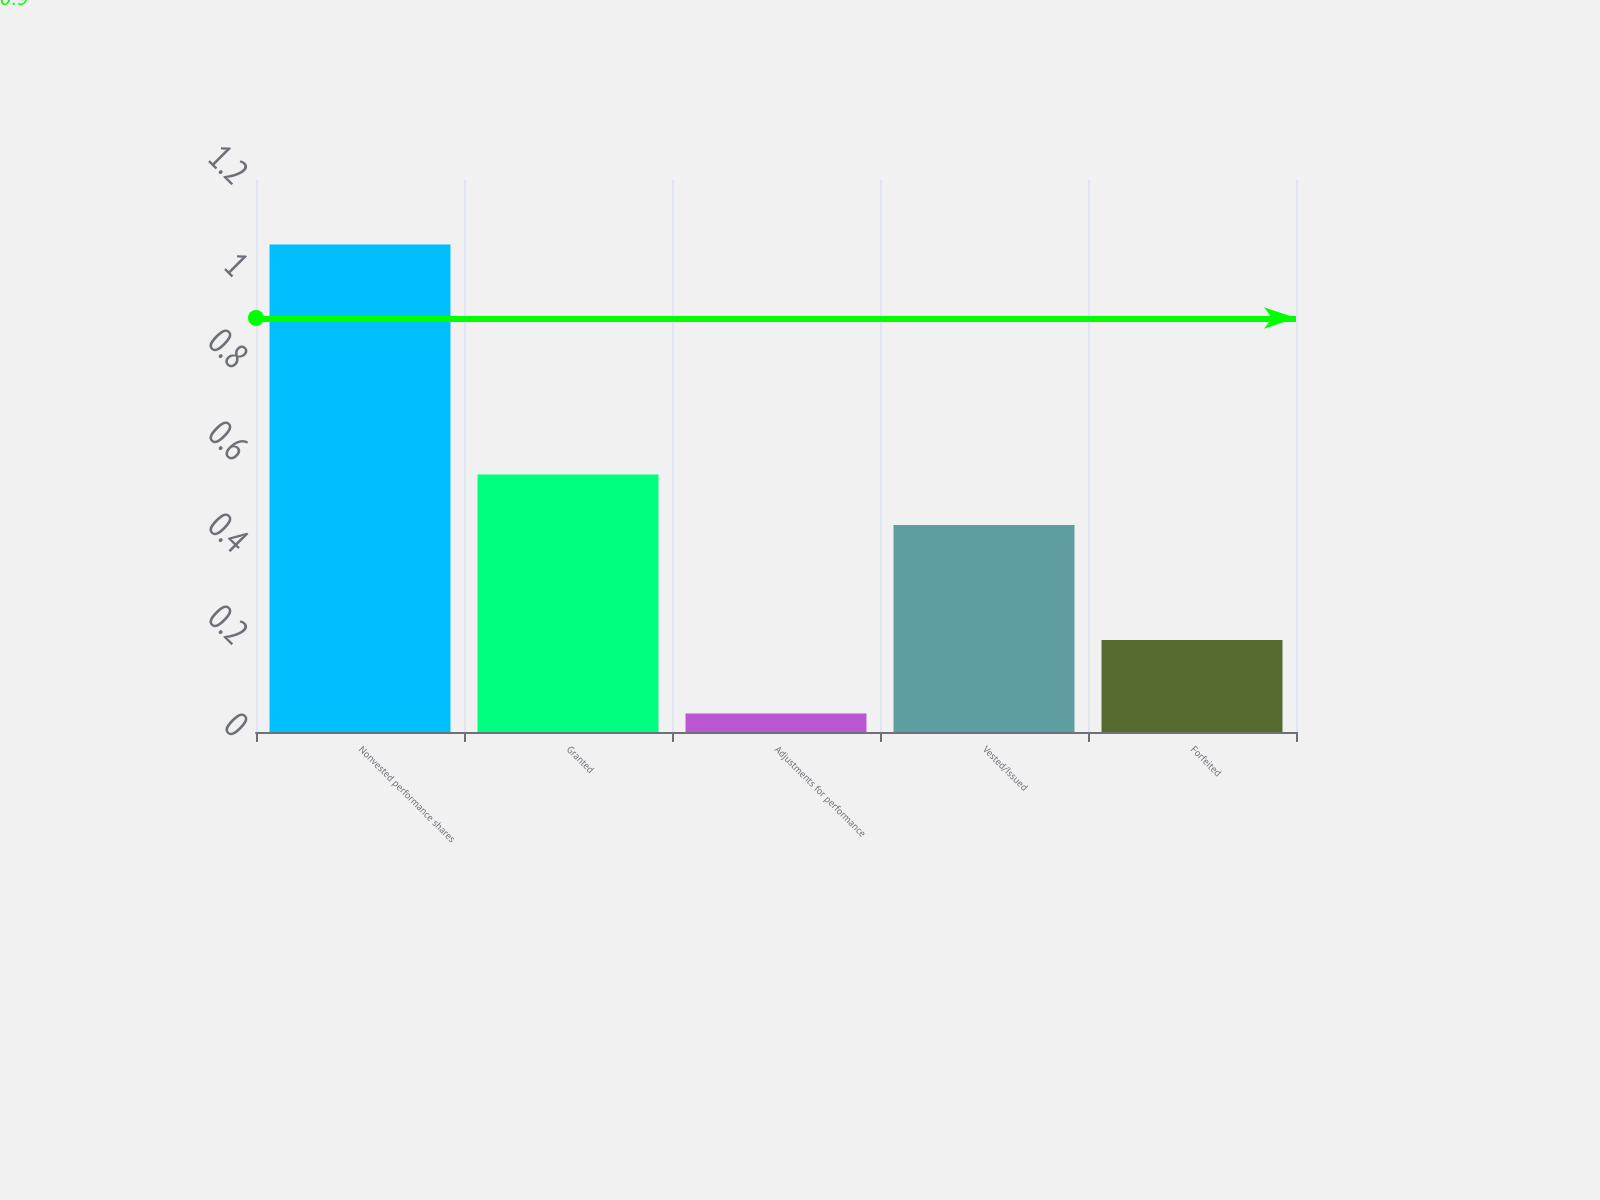<chart> <loc_0><loc_0><loc_500><loc_500><bar_chart><fcel>Nonvested performance shares<fcel>Granted<fcel>Adjustments for performance<fcel>Vested/Issued<fcel>Forfeited<nl><fcel>1.06<fcel>0.56<fcel>0.04<fcel>0.45<fcel>0.2<nl></chart> 